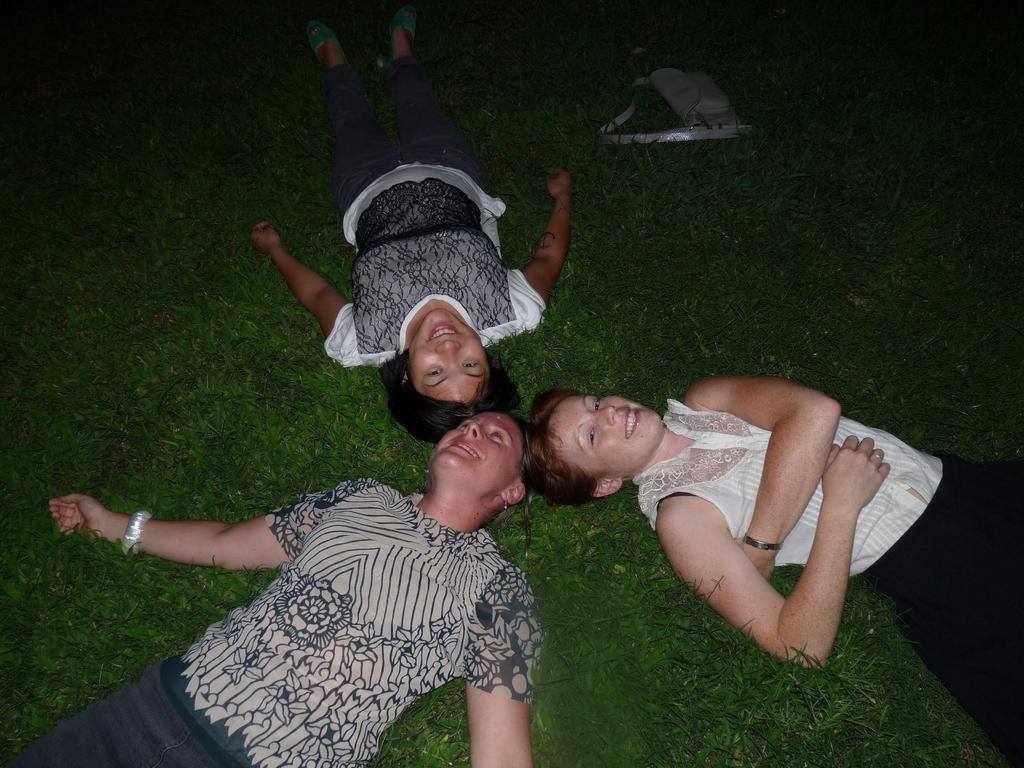How many people are lying on the grass in the image? There are three persons lying on the grass in the image. What is the position of the bag in the image? The bag is on the grass at the top of the image. How many oranges are there in the image? There are no oranges present in the image. Can you tell me how the number of persons lying on the grass increases in the image? The number of persons lying on the grass does not increase in the image; it remains constant at three. 